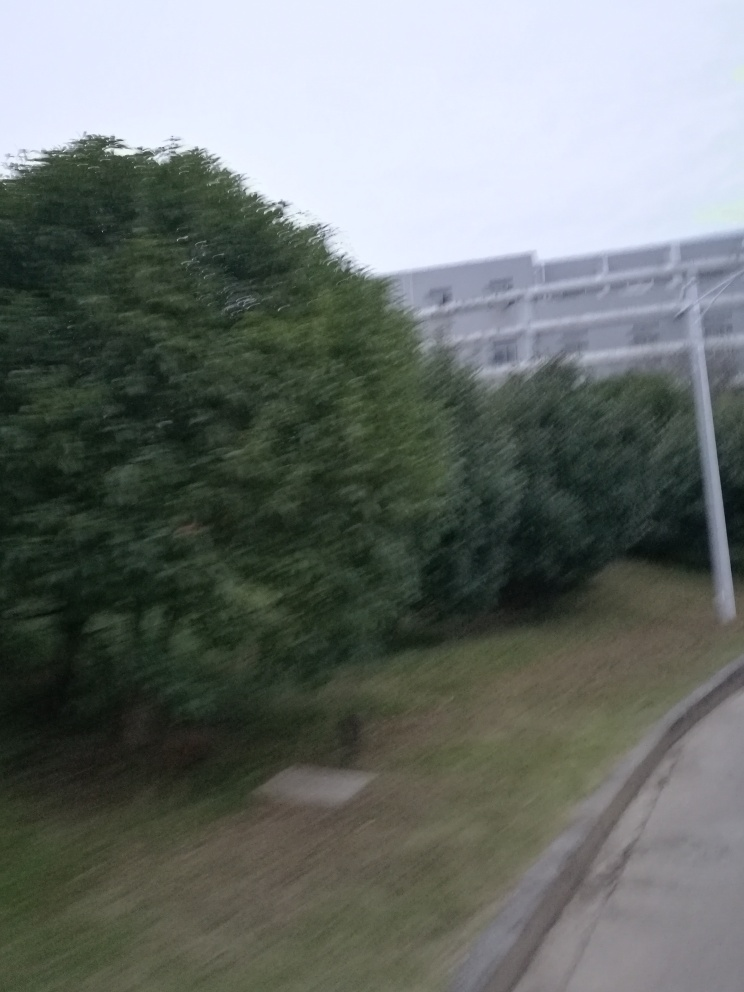What is the overall sharpness of this image?
A. Very low
B. High
C. Moderate The sharpness of the image is very low, as details are quite blurred and there's a noticeable lack of clarity and definition. Low sharpness can occur due to a number of factors, such as motion blur, incorrect camera focus, or low-quality camera sensors. In this specific case, it appears there's motion blur, possibly due to a swift camera movement or taking the photo from a moving vehicle. 